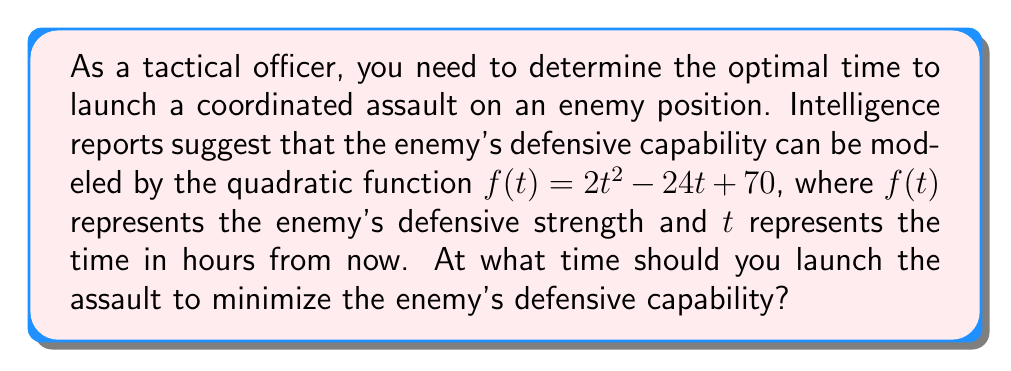Help me with this question. To find the optimal time for the assault, we need to determine when the enemy's defensive capability is at its minimum. This occurs at the vertex of the parabola represented by the quadratic function.

Given the quadratic function $f(t) = 2t^2 - 24t + 70$, we can use the quadratic formula to find the vertex:

1) The quadratic formula for the t-coordinate of the vertex is:
   $t = -\frac{b}{2a}$

2) In this case, $a = 2$ and $b = -24$:
   $t = -\frac{(-24)}{2(2)} = \frac{24}{4} = 6$

3) Therefore, the vertex occurs at $t = 6$ hours from now.

4) To verify this is a minimum (not a maximum), we can check the sign of $a$:
   Since $a = 2 > 0$, the parabola opens upward, confirming this is indeed a minimum.

5) We can calculate the minimum defensive strength:
   $f(6) = 2(6)^2 - 24(6) + 70 = 72 - 144 + 70 = -2$

This negative value might seem unrealistic for defensive strength, but it represents the point of maximum vulnerability relative to the starting condition.
Answer: The optimal time to launch the assault is 6 hours from now, when the enemy's defensive capability will be at its minimum. 